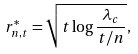Convert formula to latex. <formula><loc_0><loc_0><loc_500><loc_500>r _ { n , t } ^ { * } = \sqrt { t \log \frac { \lambda _ { c } } { t / n } } ,</formula> 